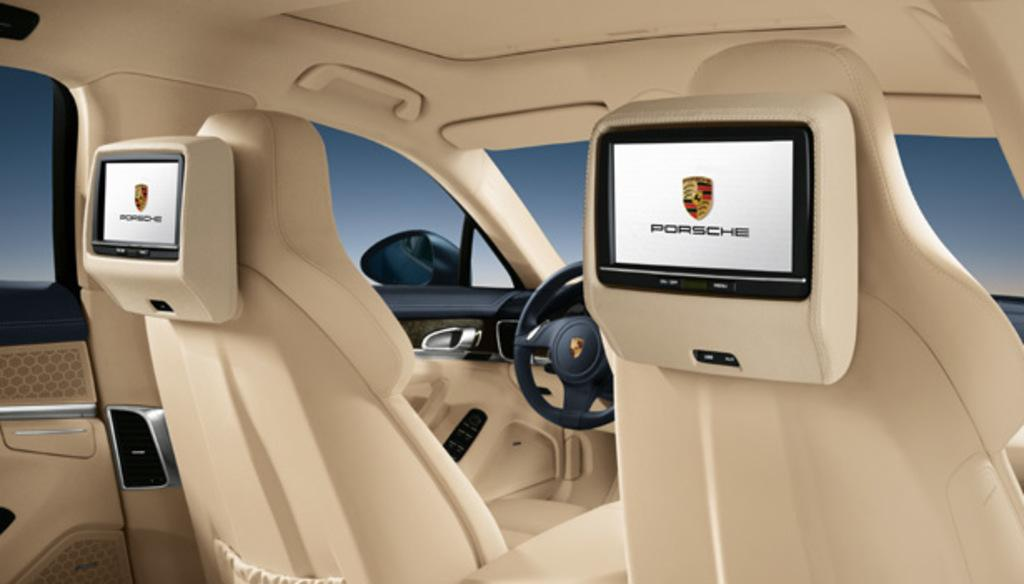What type of space is depicted in the image? The image shows the inside view of a vehicle. What is the main control device in the vehicle? There is a steering wheel in the vehicle. What additional features are present in the vehicle? There are screens attached to the back of the seats. What can be seen on the screens? There is text visible on the screens. Can you see the grandfather playing with the cub on the screens? There is no mention of a grandfather or a cub in the image, and therefore no such activity can be observed on the screens. 